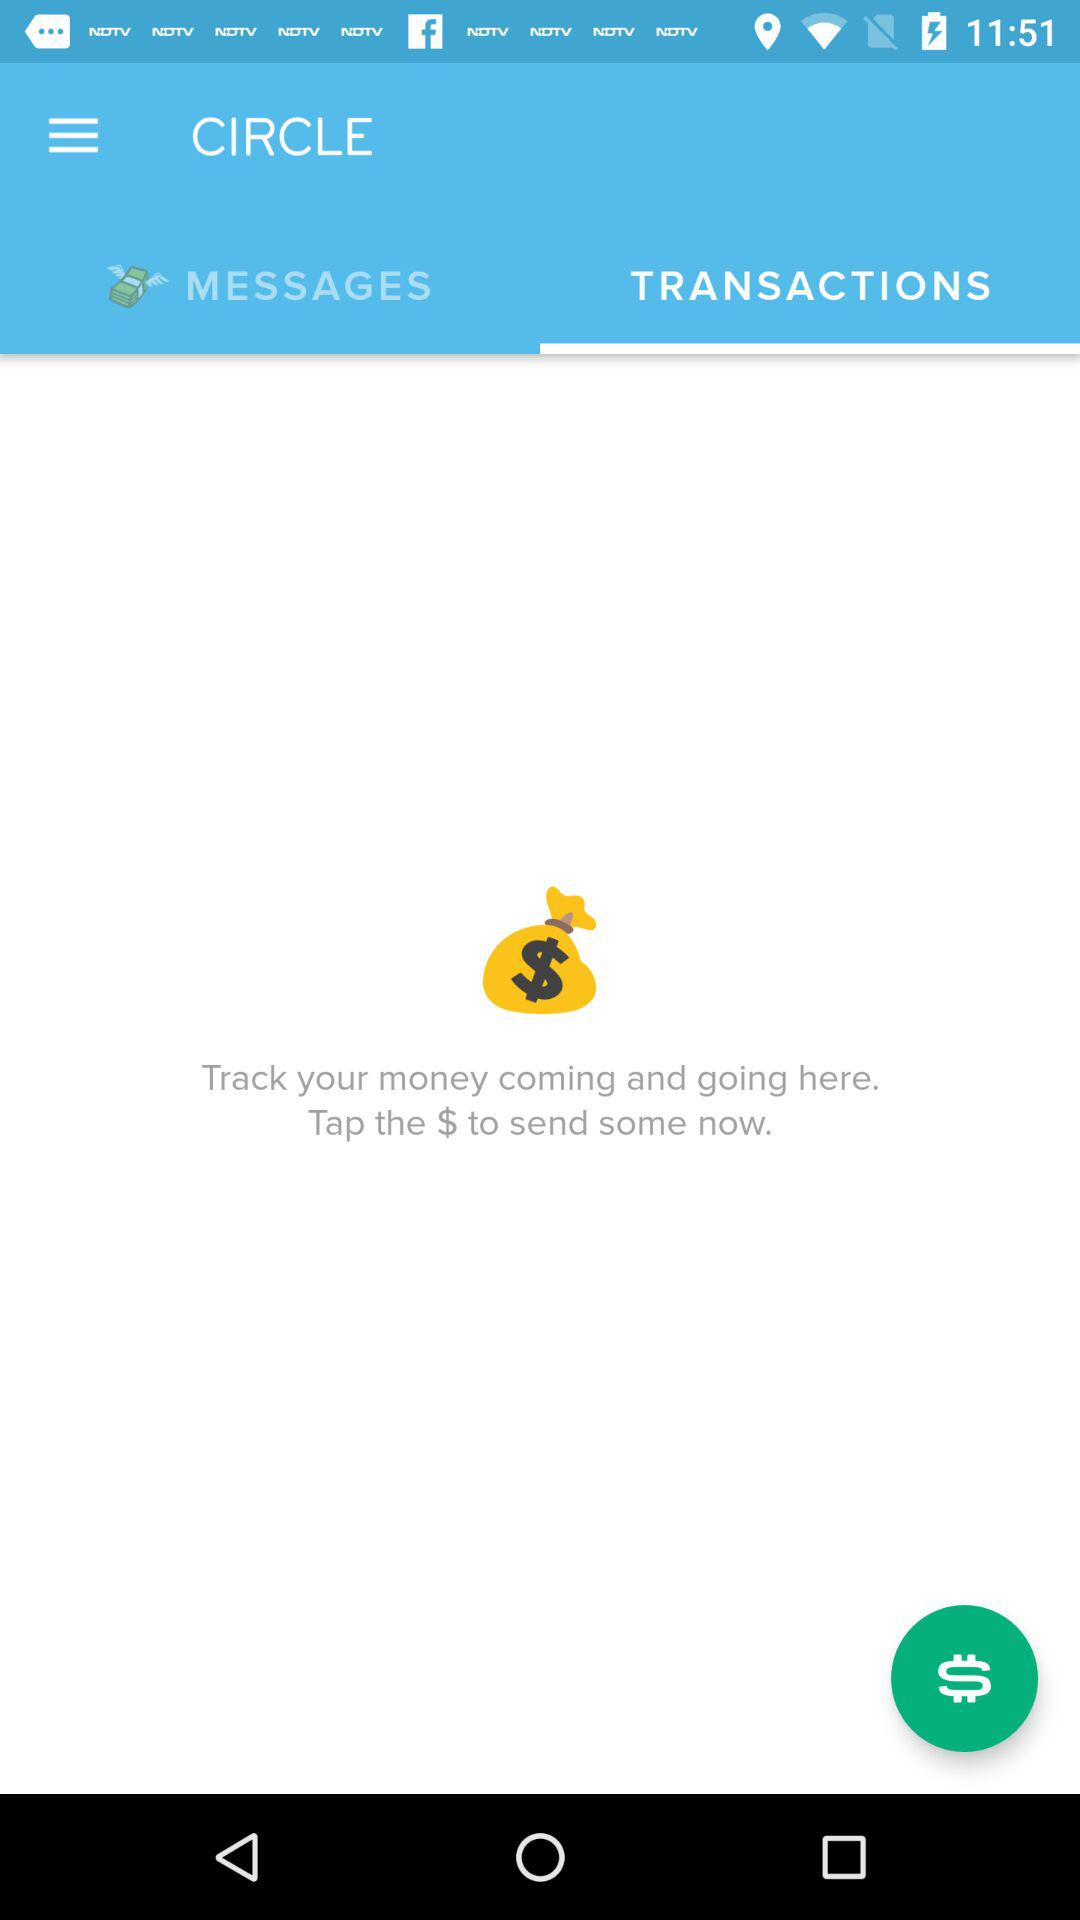Which tab is selected? The selected tab is "TRANSACTIONS". 